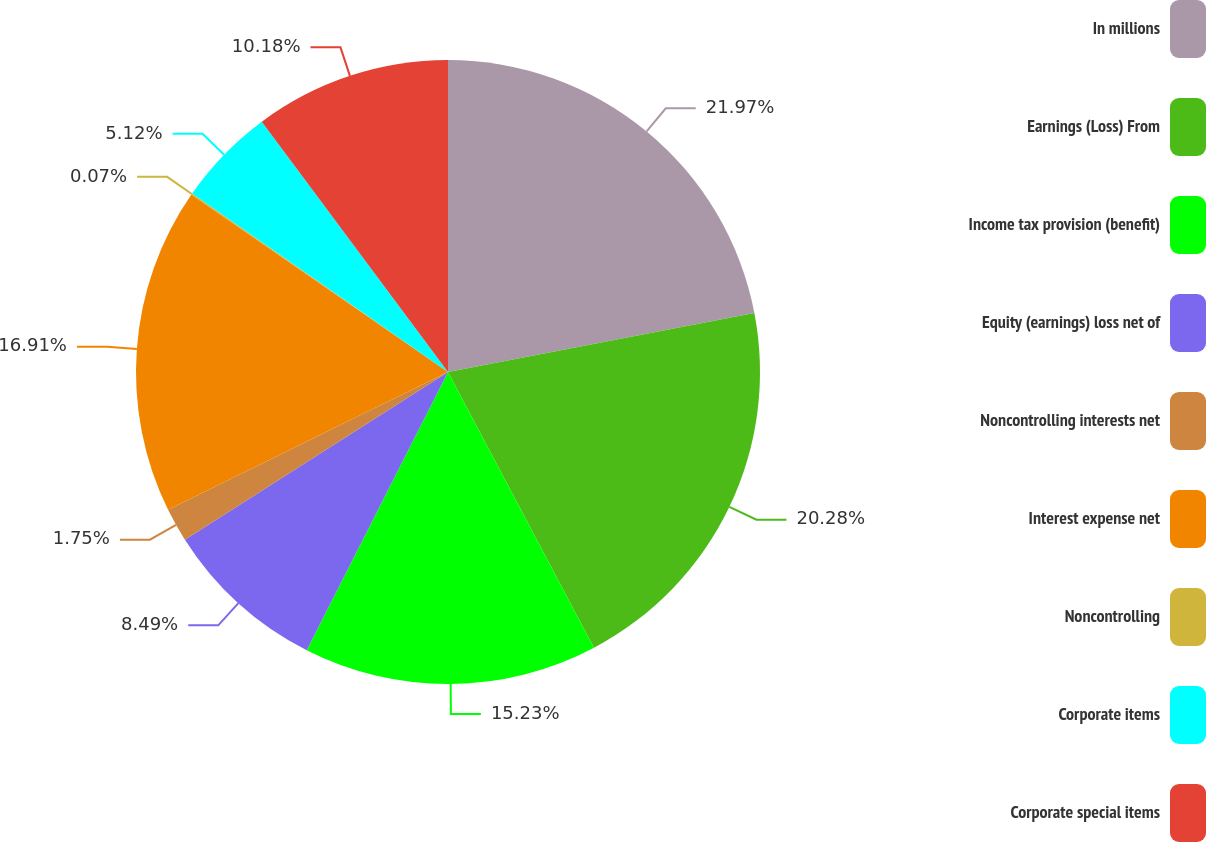<chart> <loc_0><loc_0><loc_500><loc_500><pie_chart><fcel>In millions<fcel>Earnings (Loss) From<fcel>Income tax provision (benefit)<fcel>Equity (earnings) loss net of<fcel>Noncontrolling interests net<fcel>Interest expense net<fcel>Noncontrolling<fcel>Corporate items<fcel>Corporate special items<nl><fcel>21.97%<fcel>20.28%<fcel>15.23%<fcel>8.49%<fcel>1.75%<fcel>16.91%<fcel>0.07%<fcel>5.12%<fcel>10.18%<nl></chart> 